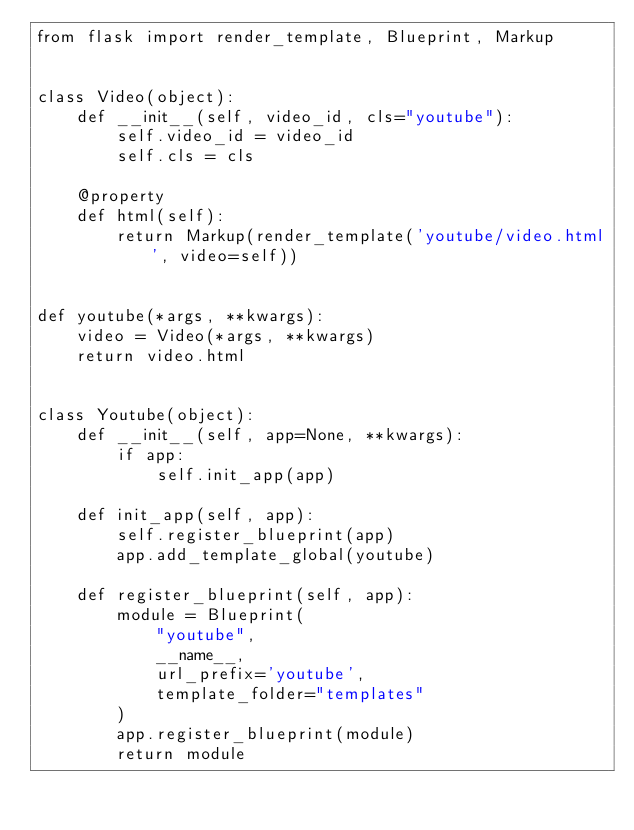Convert code to text. <code><loc_0><loc_0><loc_500><loc_500><_Python_>from flask import render_template, Blueprint, Markup


class Video(object):
    def __init__(self, video_id, cls="youtube"):
        self.video_id = video_id
        self.cls = cls

    @property
    def html(self):
        return Markup(render_template('youtube/video.html', video=self))


def youtube(*args, **kwargs):
    video = Video(*args, **kwargs)
    return video.html


class Youtube(object):
    def __init__(self, app=None, **kwargs):
        if app:
            self.init_app(app)

    def init_app(self, app):
        self.register_blueprint(app)
        app.add_template_global(youtube)

    def register_blueprint(self, app):
        module = Blueprint(
            "youtube",
            __name__,
            url_prefix='youtube',
            template_folder="templates"
        )
        app.register_blueprint(module)
        return module
</code> 